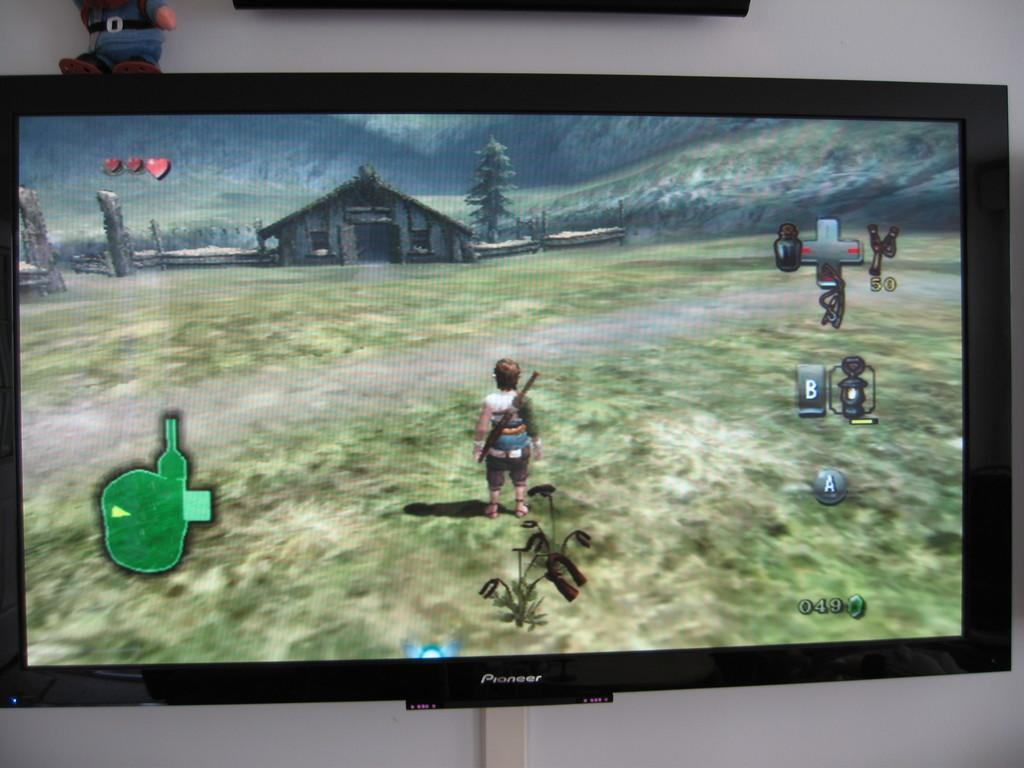<image>
Share a concise interpretation of the image provided. a television that has a lot of different characters on it and the tv is a Pioneer 